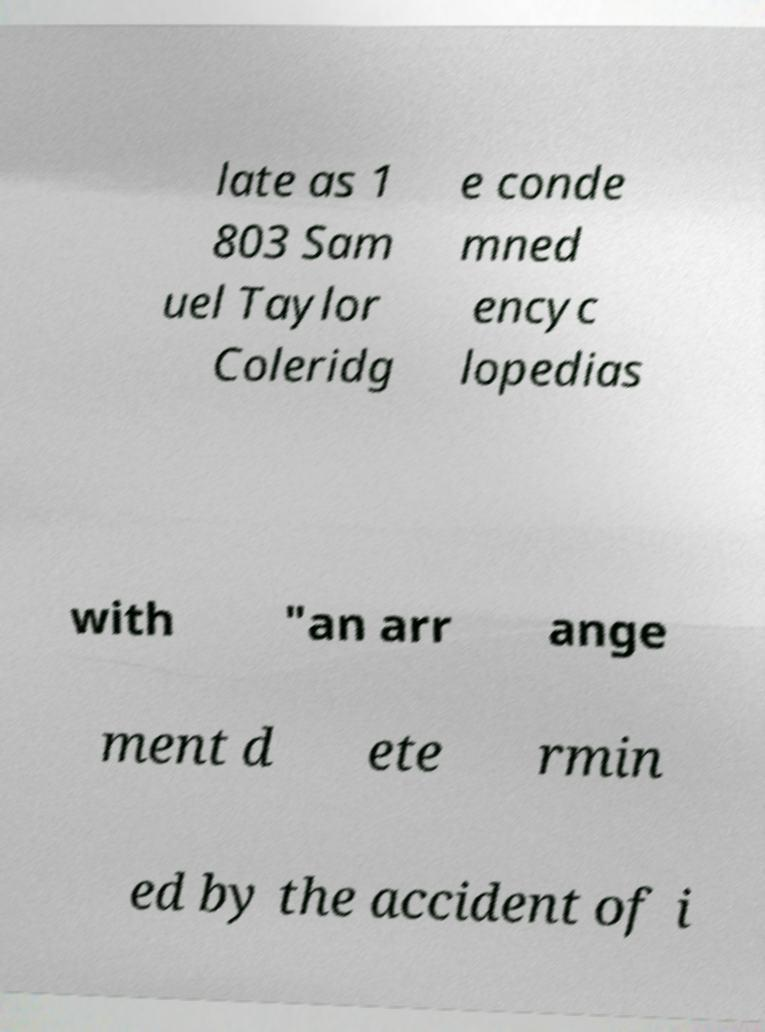I need the written content from this picture converted into text. Can you do that? late as 1 803 Sam uel Taylor Coleridg e conde mned encyc lopedias with "an arr ange ment d ete rmin ed by the accident of i 